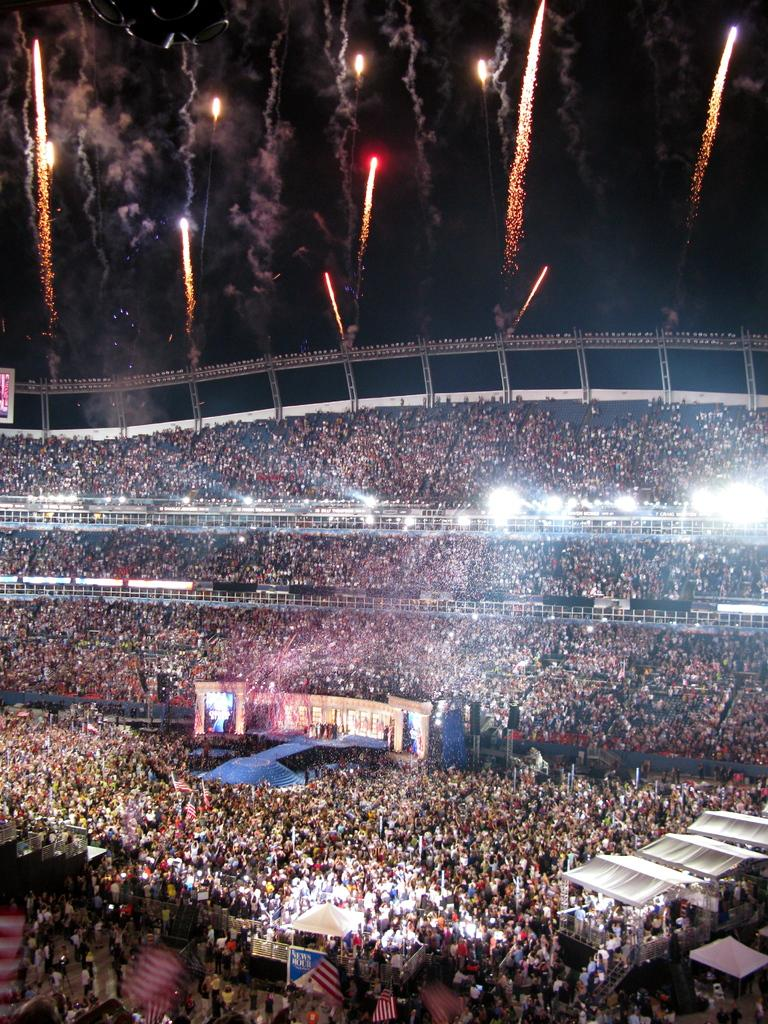How many people can be seen in the image? There are many people in the image. What can be seen illuminated in the image? There are lights visible in the image. What symbols or emblems are present in the image? There are flags in the image. What is happening at the top of the image? Fireworks are present at the top of the image. Can you see a receipt in the image? There is no receipt present in the image. What type of owl can be seen in the image? There is no owl present in the image. 